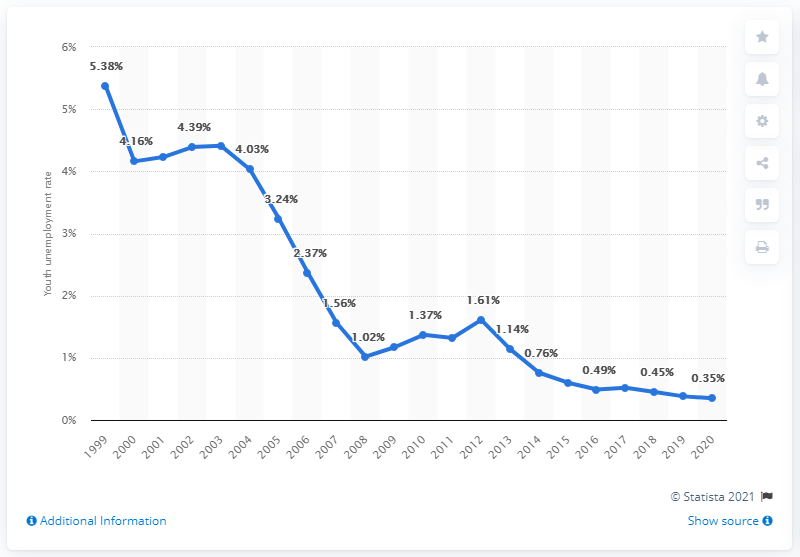Outline some significant characteristics in this image. In 2020, the youth unemployment rate in Qatar was 0.35%. 